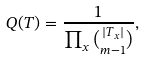Convert formula to latex. <formula><loc_0><loc_0><loc_500><loc_500>Q ( T ) = \frac { 1 } { \prod _ { x } \binom { | T _ { x } | } { m - 1 } } ,</formula> 